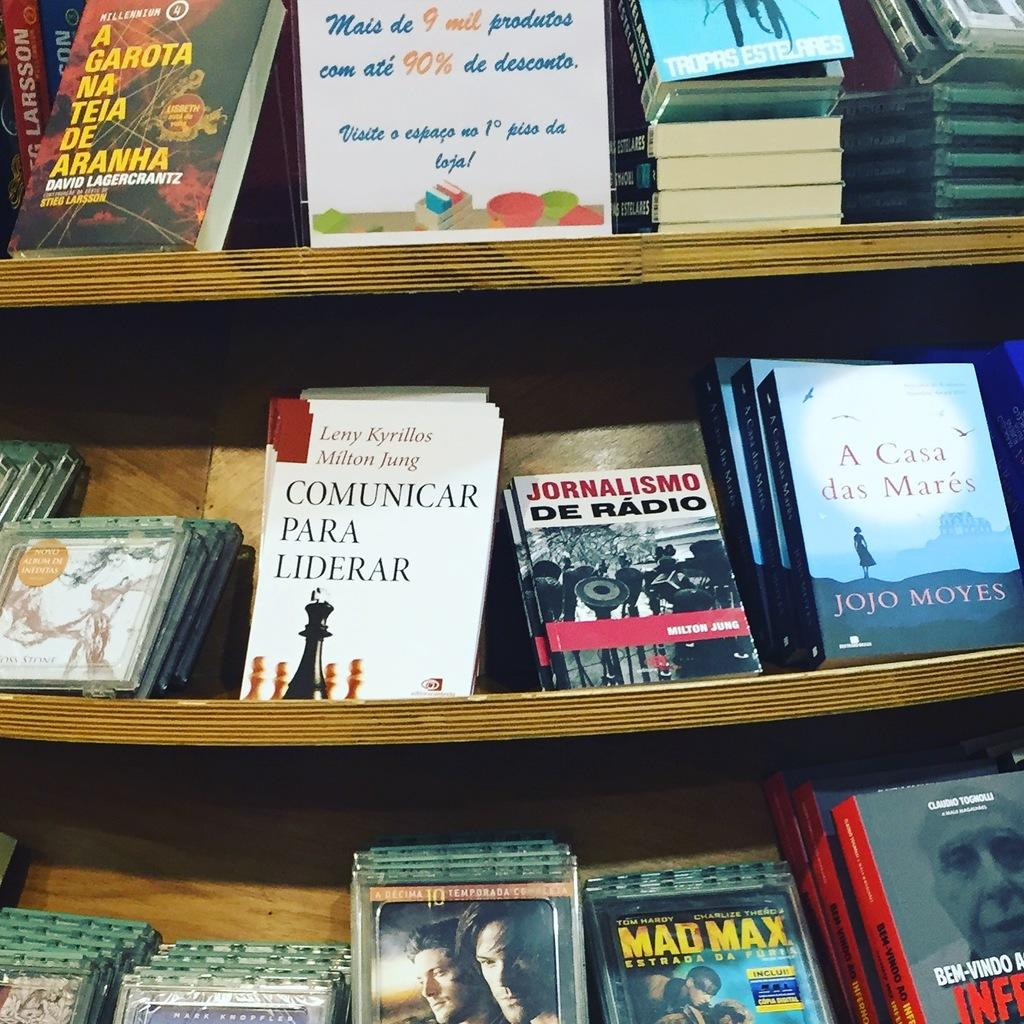<image>
Give a short and clear explanation of the subsequent image. the term Mad Max is on the front of the DVD 